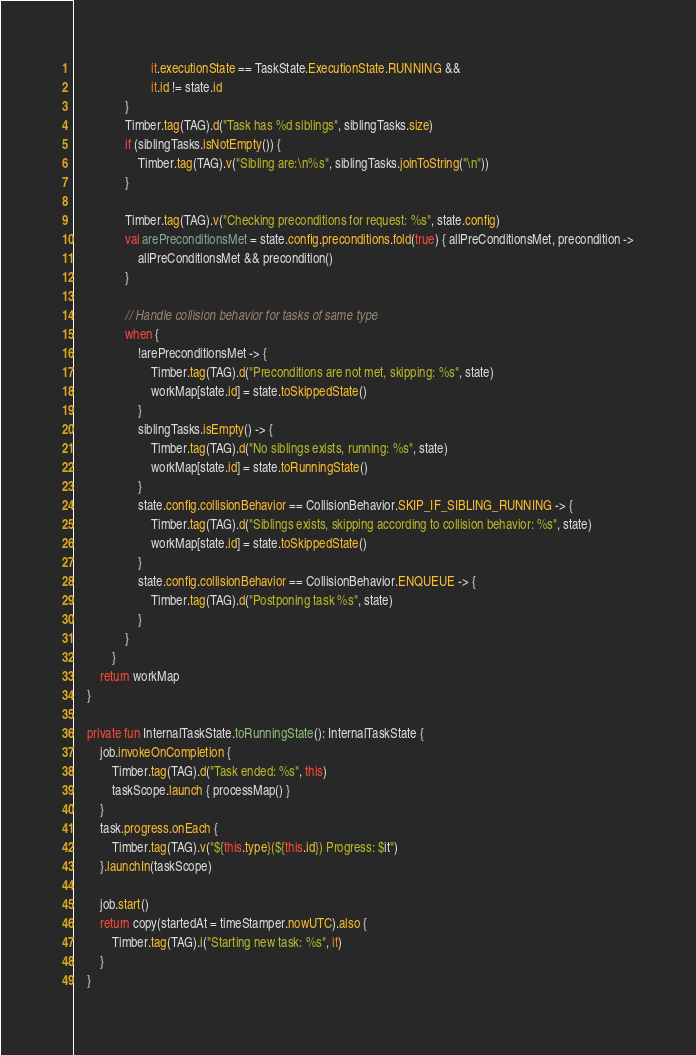Convert code to text. <code><loc_0><loc_0><loc_500><loc_500><_Kotlin_>                        it.executionState == TaskState.ExecutionState.RUNNING &&
                        it.id != state.id
                }
                Timber.tag(TAG).d("Task has %d siblings", siblingTasks.size)
                if (siblingTasks.isNotEmpty()) {
                    Timber.tag(TAG).v("Sibling are:\n%s", siblingTasks.joinToString("\n"))
                }

                Timber.tag(TAG).v("Checking preconditions for request: %s", state.config)
                val arePreconditionsMet = state.config.preconditions.fold(true) { allPreConditionsMet, precondition ->
                    allPreConditionsMet && precondition()
                }

                // Handle collision behavior for tasks of same type
                when {
                    !arePreconditionsMet -> {
                        Timber.tag(TAG).d("Preconditions are not met, skipping: %s", state)
                        workMap[state.id] = state.toSkippedState()
                    }
                    siblingTasks.isEmpty() -> {
                        Timber.tag(TAG).d("No siblings exists, running: %s", state)
                        workMap[state.id] = state.toRunningState()
                    }
                    state.config.collisionBehavior == CollisionBehavior.SKIP_IF_SIBLING_RUNNING -> {
                        Timber.tag(TAG).d("Siblings exists, skipping according to collision behavior: %s", state)
                        workMap[state.id] = state.toSkippedState()
                    }
                    state.config.collisionBehavior == CollisionBehavior.ENQUEUE -> {
                        Timber.tag(TAG).d("Postponing task %s", state)
                    }
                }
            }
        return workMap
    }

    private fun InternalTaskState.toRunningState(): InternalTaskState {
        job.invokeOnCompletion {
            Timber.tag(TAG).d("Task ended: %s", this)
            taskScope.launch { processMap() }
        }
        task.progress.onEach {
            Timber.tag(TAG).v("${this.type}(${this.id}) Progress: $it")
        }.launchIn(taskScope)

        job.start()
        return copy(startedAt = timeStamper.nowUTC).also {
            Timber.tag(TAG).i("Starting new task: %s", it)
        }
    }
</code> 